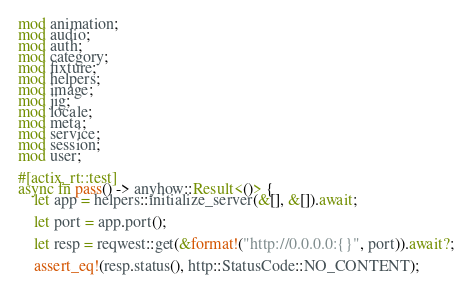Convert code to text. <code><loc_0><loc_0><loc_500><loc_500><_Rust_>mod animation;
mod audio;
mod auth;
mod category;
mod fixture;
mod helpers;
mod image;
mod jig;
mod locale;
mod meta;
mod service;
mod session;
mod user;

#[actix_rt::test]
async fn pass() -> anyhow::Result<()> {
    let app = helpers::initialize_server(&[], &[]).await;

    let port = app.port();

    let resp = reqwest::get(&format!("http://0.0.0.0:{}", port)).await?;

    assert_eq!(resp.status(), http::StatusCode::NO_CONTENT);
</code> 